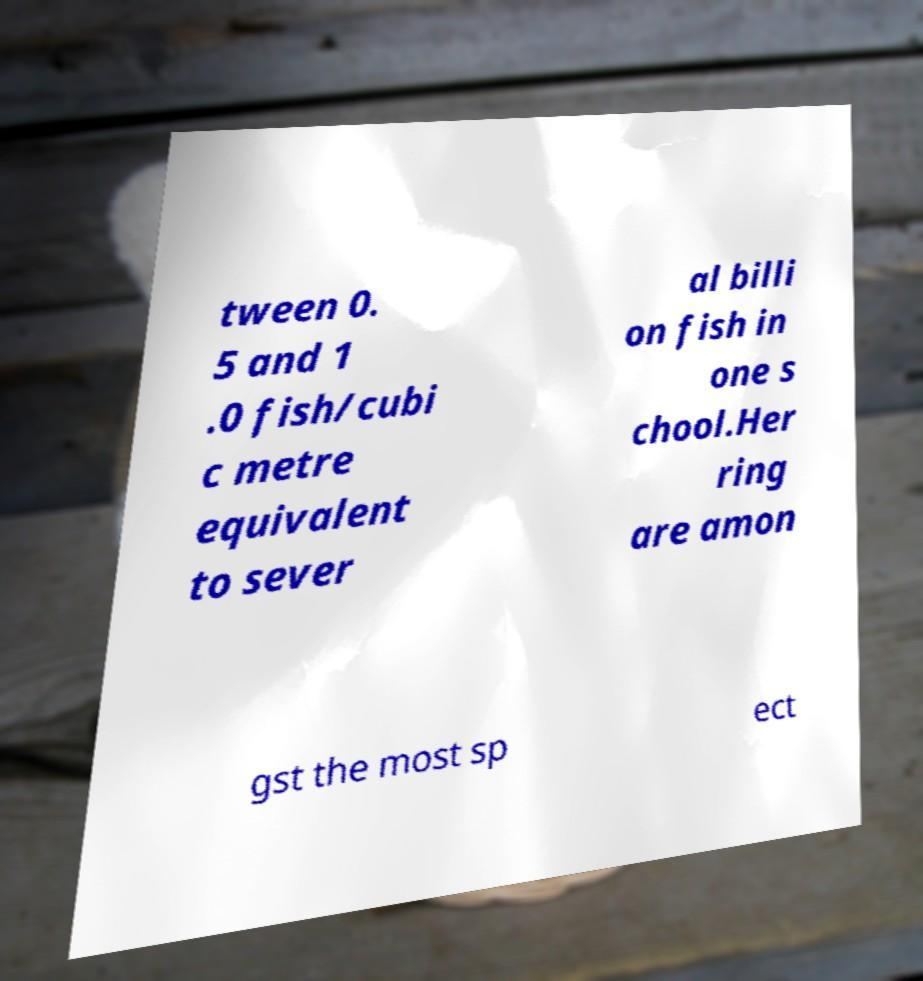What messages or text are displayed in this image? I need them in a readable, typed format. tween 0. 5 and 1 .0 fish/cubi c metre equivalent to sever al billi on fish in one s chool.Her ring are amon gst the most sp ect 